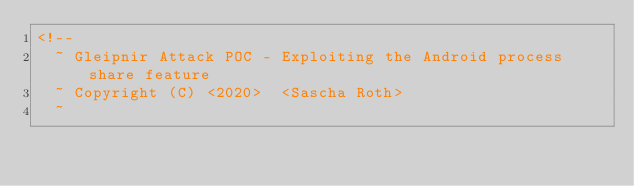Convert code to text. <code><loc_0><loc_0><loc_500><loc_500><_XML_><!--
  ~ Gleipnir Attack POC - Exploiting the Android process share feature
  ~ Copyright (C) <2020>  <Sascha Roth>
  ~</code> 